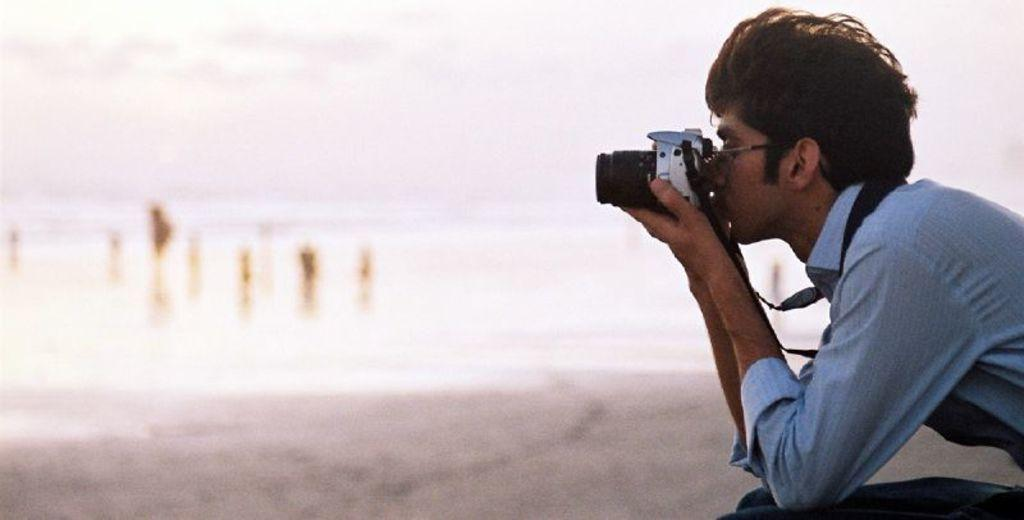What is the main subject of the image? There is a person in the image. What is the person wearing? The person is wearing a blue shirt. What object is the person holding in their hand? The person is holding a camera in their hand. What type of wristwatch is the person wearing in the image? There is no wristwatch visible in the image; the person is wearing a blue shirt. What gardening tool is the person using in the image? There is no gardening tool present in the image; the person is holding a camera. 